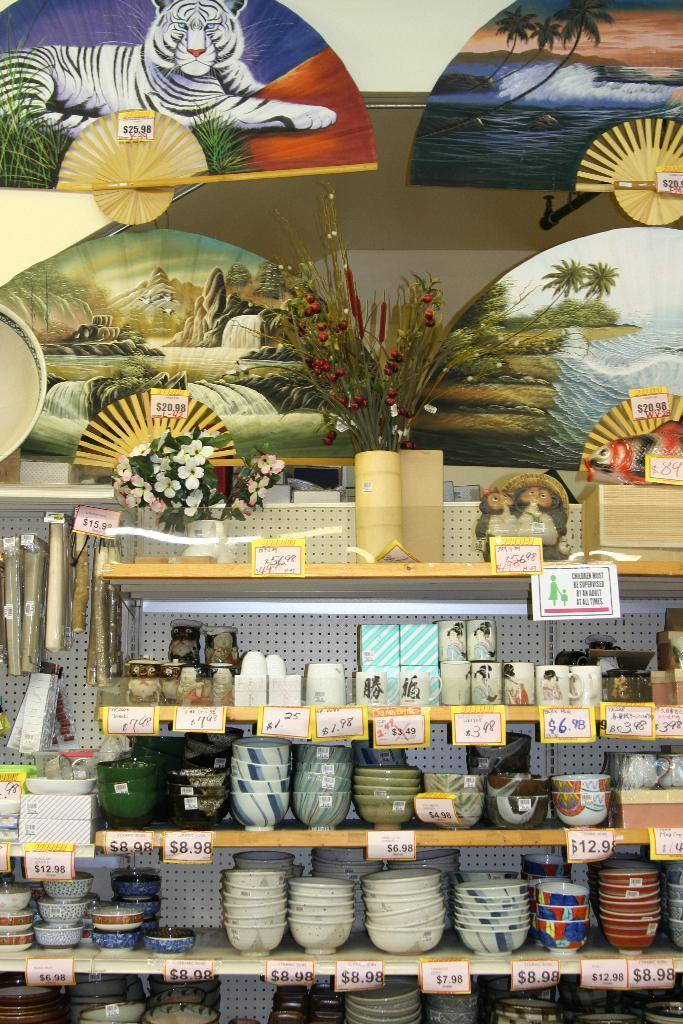Can you describe this image briefly? In this picture we can see bowls, cups, boxes, price tags, flowers and these all are placed in racks and in the background we can see wall. 